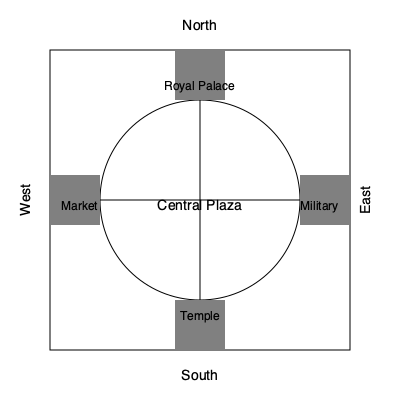In this diagram of an ancient Persian city, which structure is positioned directly opposite to the Royal Palace, and what historical significance might this arrangement hold? 1. Observe the layout of the city:
   - The city is represented by a square with a circular central area.
   - Four main structures are positioned at the cardinal points.

2. Identify the structures:
   - North: Royal Palace
   - South: Temple
   - West: Market
   - East: Military quarter

3. Determine the opposite structure to the Royal Palace:
   - The Royal Palace is in the north.
   - Directly opposite (south) is the Temple.

4. Historical significance of this arrangement:
   - This layout reflects the chahar bagh (four gardens) design principle in Persian architecture.
   - The opposition of the Royal Palace and Temple symbolizes the balance between secular and religious power.
   - This arrangement emphasizes the importance of both political and spiritual authority in ancient Persian society.
   - The central plaza acts as a unifying space, potentially representing the role of the public in balancing these powers.
   - This design showcases the sophisticated urban planning of ancient Persians, integrating governance, religion, commerce, and military in a harmonious layout.

5. The positioning also allows for:
   - Easy access to all major city functions from the central plaza.
   - Clear sight lines between the palace and temple, possibly for ceremonies or processions.
   - Efficient city defense, with the military quarter positioned to protect the eastern flank.
Answer: Temple; balancing secular and religious power 